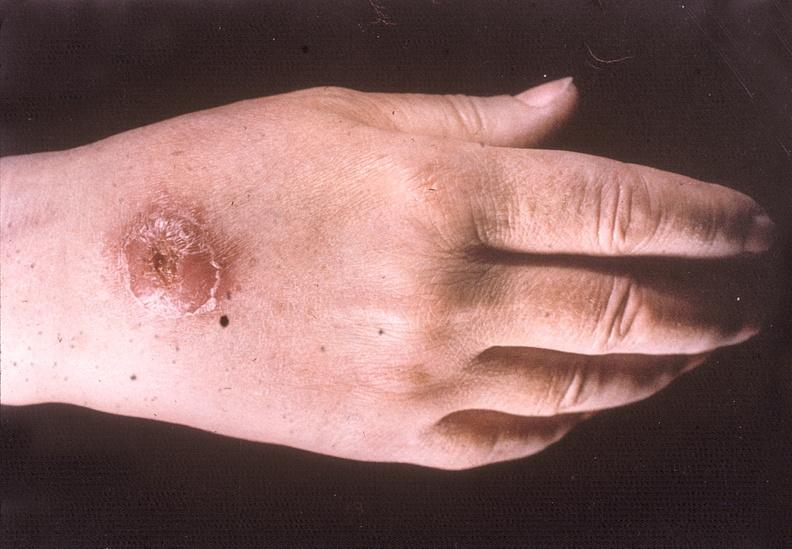what are present?
Answer the question using a single word or phrase. Extremities 